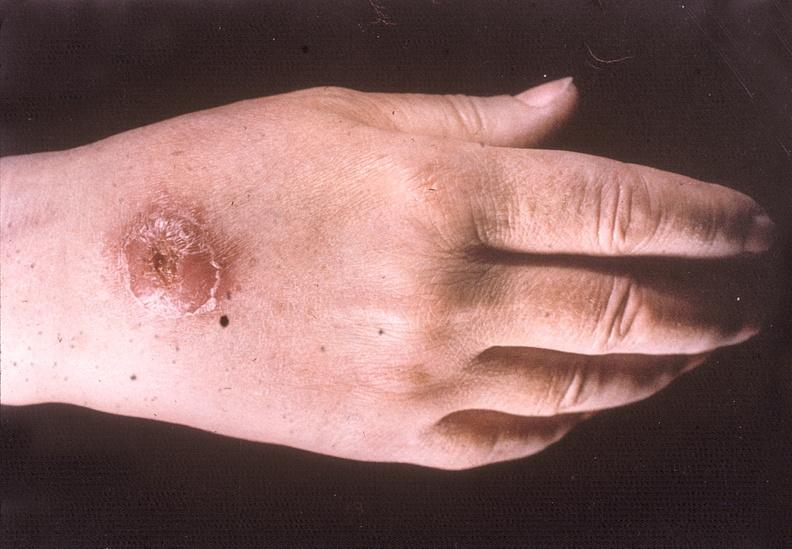what are present?
Answer the question using a single word or phrase. Extremities 